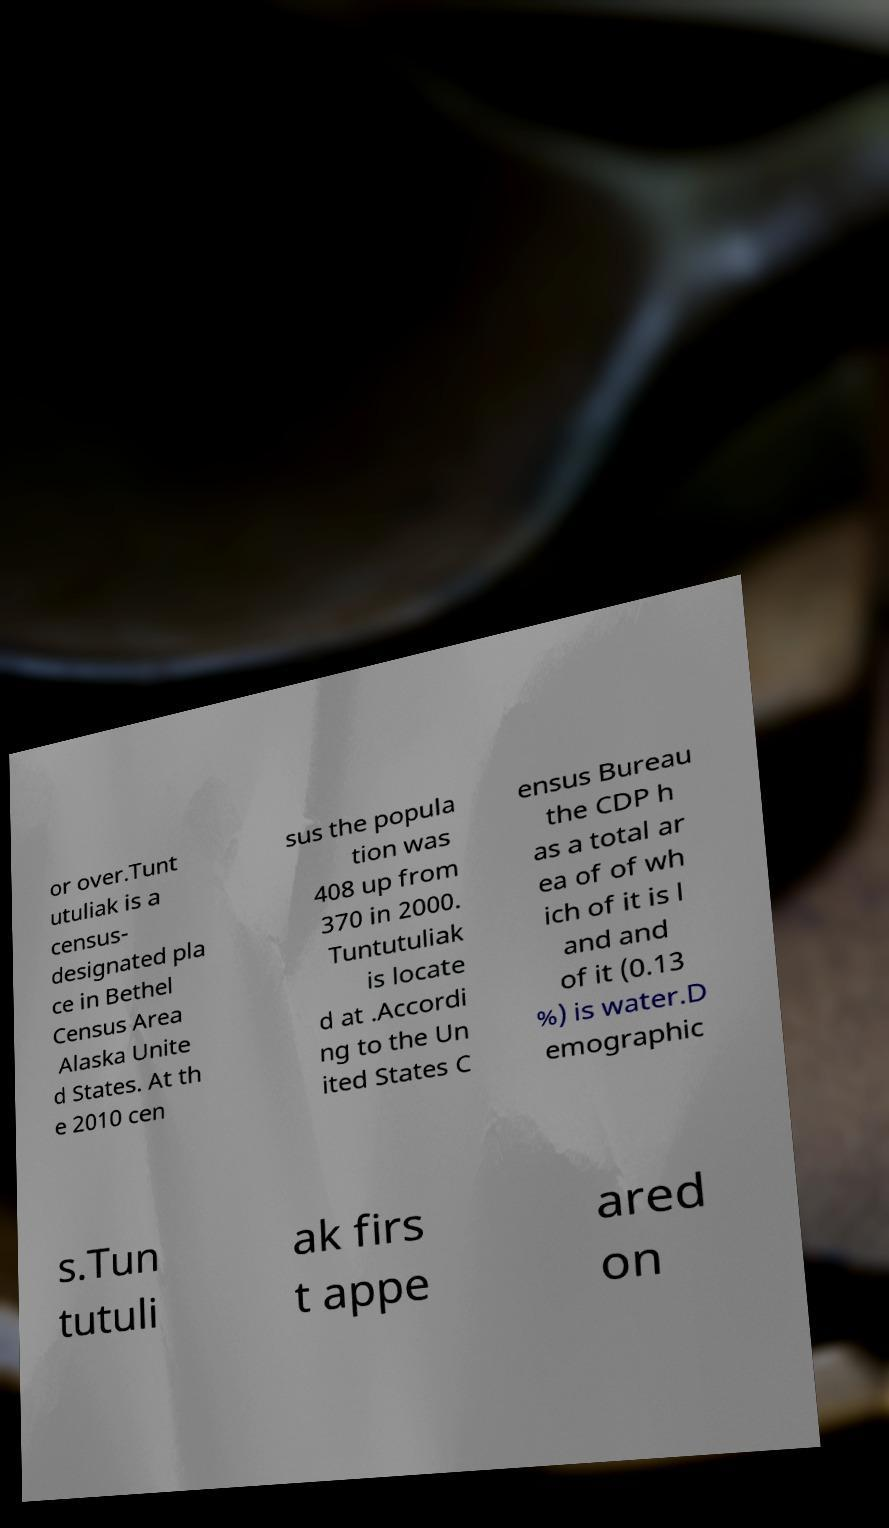There's text embedded in this image that I need extracted. Can you transcribe it verbatim? or over.Tunt utuliak is a census- designated pla ce in Bethel Census Area Alaska Unite d States. At th e 2010 cen sus the popula tion was 408 up from 370 in 2000. Tuntutuliak is locate d at .Accordi ng to the Un ited States C ensus Bureau the CDP h as a total ar ea of of wh ich of it is l and and of it (0.13 %) is water.D emographic s.Tun tutuli ak firs t appe ared on 